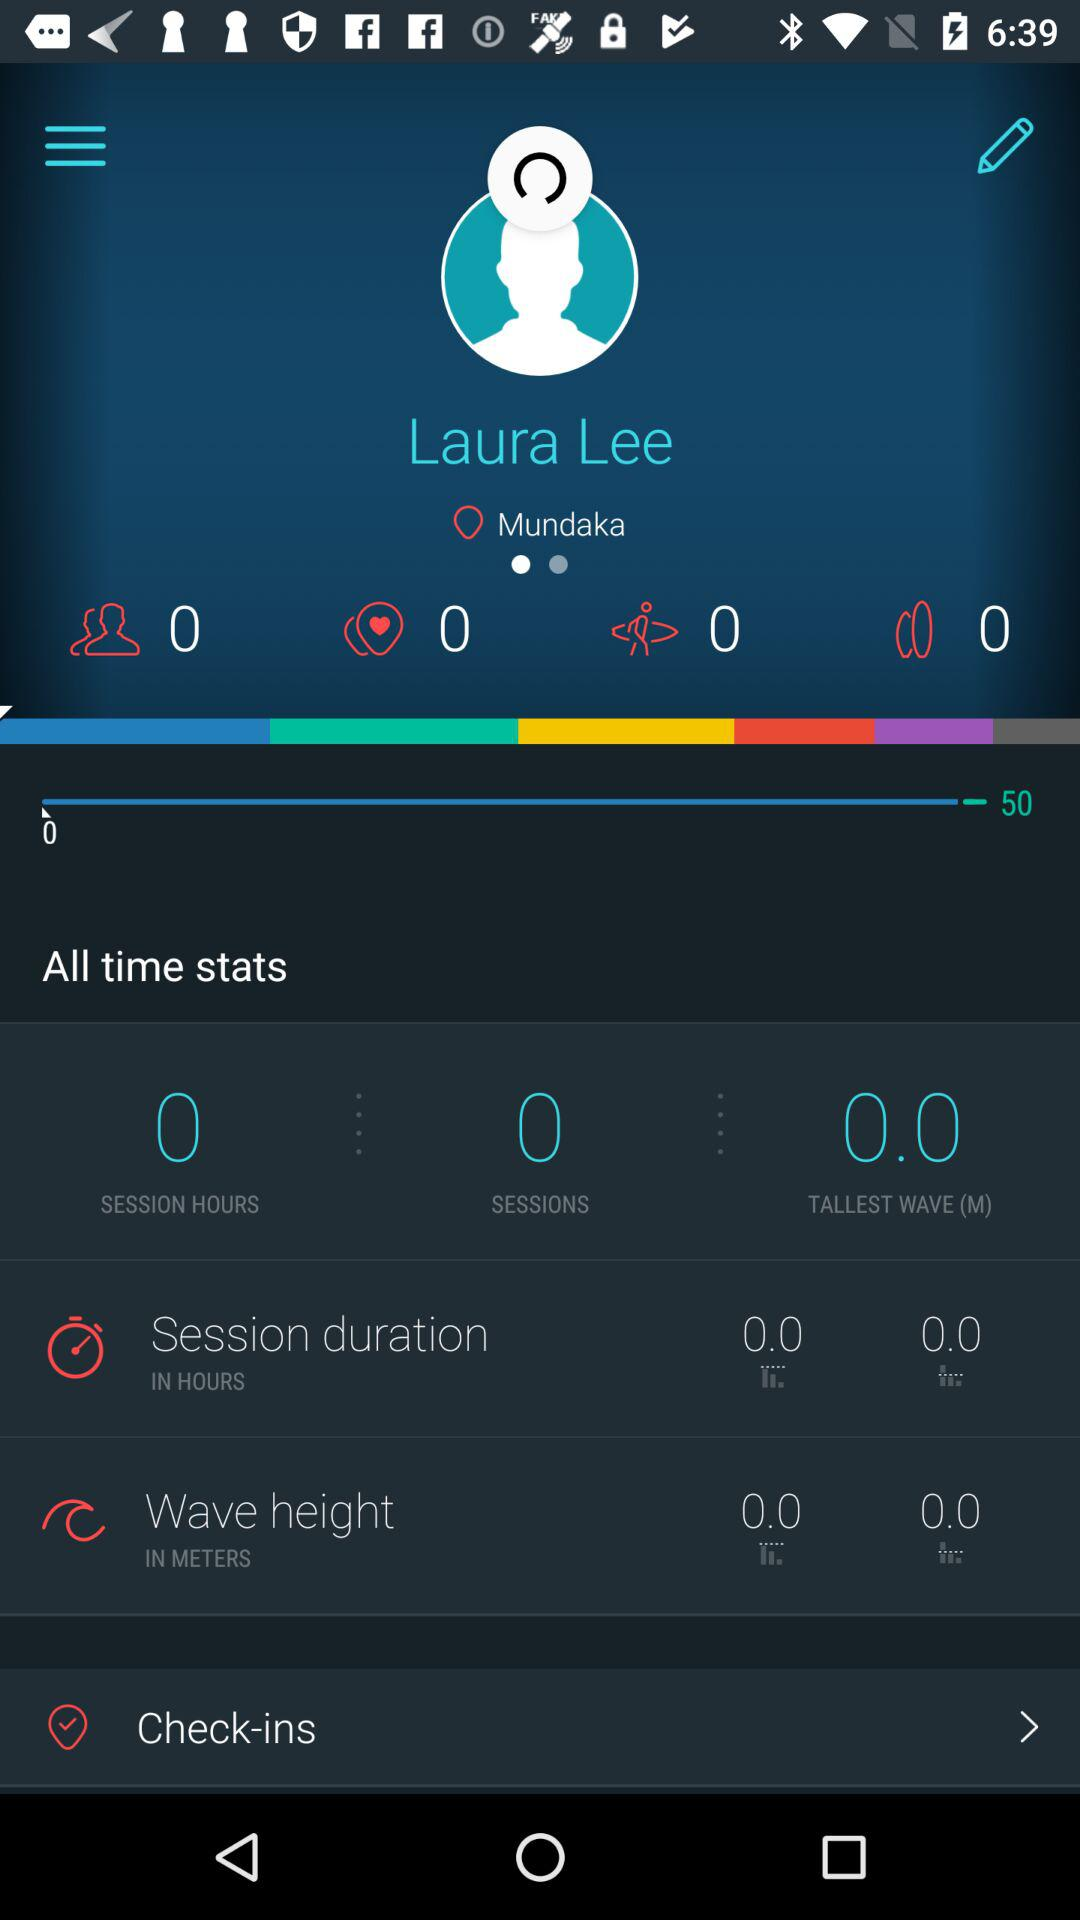Which unit is the wave height measured in? The wave height is measured in meters. 